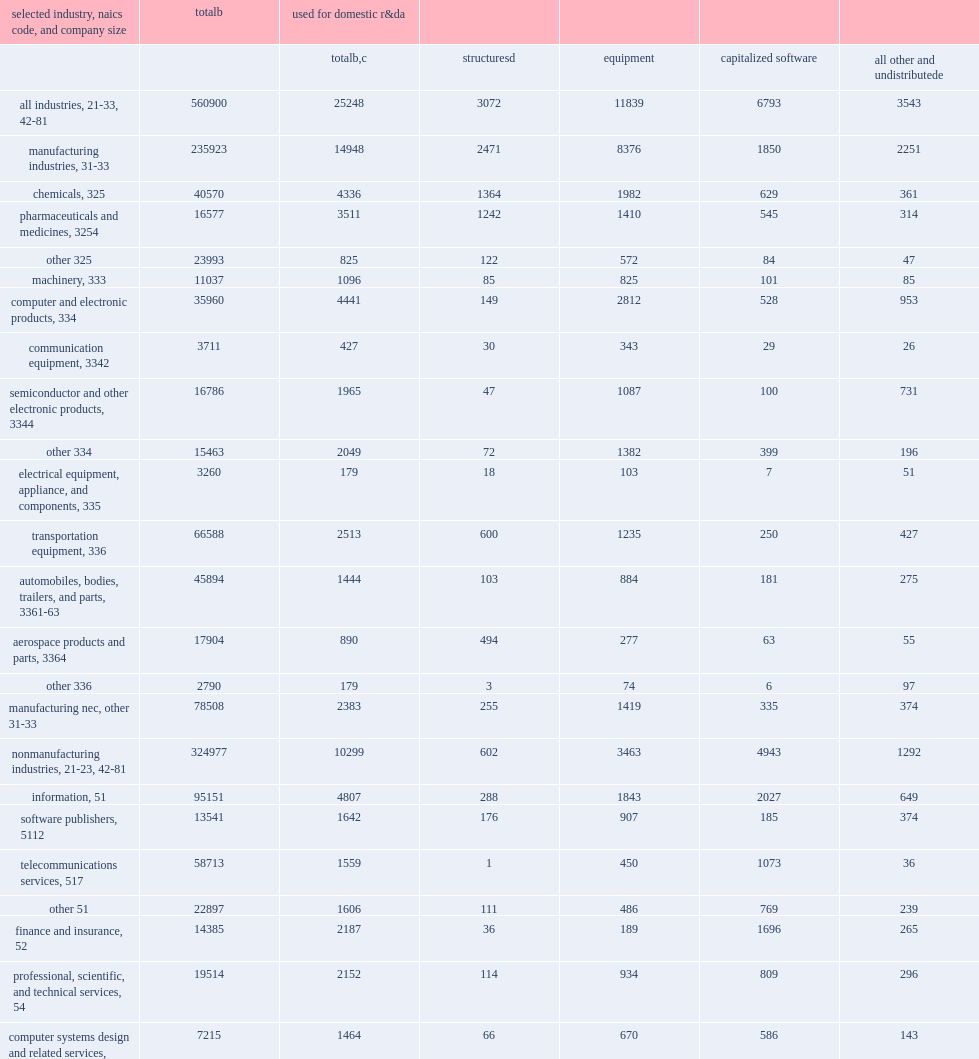How many million dollars did companies that performed or funded r&d in the united states in 2016 spend on assets with expected useful lives of more than 1 year? 560900.0. How many million dollars were spent on structures, equipment, software, and other assets used for r&d? 25248.0. How many million dollars were spent by manufacturing industries? 14948.0. How many million dollars were spent by nonmanufacturing industries? 10299.0. Give me the full table as a dictionary. {'header': ['selected industry, naics code, and company size', 'totalb', 'used for domestic r&da', '', '', '', ''], 'rows': [['', '', 'totalb,c', 'structuresd', 'equipment', 'capitalized software', 'all other and undistributede'], ['all industries, 21-33, 42-81', '560900', '25248', '3072', '11839', '6793', '3543'], ['manufacturing industries, 31-33', '235923', '14948', '2471', '8376', '1850', '2251'], ['chemicals, 325', '40570', '4336', '1364', '1982', '629', '361'], ['pharmaceuticals and medicines, 3254', '16577', '3511', '1242', '1410', '545', '314'], ['other 325', '23993', '825', '122', '572', '84', '47'], ['machinery, 333', '11037', '1096', '85', '825', '101', '85'], ['computer and electronic products, 334', '35960', '4441', '149', '2812', '528', '953'], ['communication equipment, 3342', '3711', '427', '30', '343', '29', '26'], ['semiconductor and other electronic products, 3344', '16786', '1965', '47', '1087', '100', '731'], ['other 334', '15463', '2049', '72', '1382', '399', '196'], ['electrical equipment, appliance, and components, 335', '3260', '179', '18', '103', '7', '51'], ['transportation equipment, 336', '66588', '2513', '600', '1235', '250', '427'], ['automobiles, bodies, trailers, and parts, 3361-63', '45894', '1444', '103', '884', '181', '275'], ['aerospace products and parts, 3364', '17904', '890', '494', '277', '63', '55'], ['other 336', '2790', '179', '3', '74', '6', '97'], ['manufacturing nec, other 31-33', '78508', '2383', '255', '1419', '335', '374'], ['nonmanufacturing industries, 21-23, 42-81', '324977', '10299', '602', '3463', '4943', '1292'], ['information, 51', '95151', '4807', '288', '1843', '2027', '649'], ['software publishers, 5112', '13541', '1642', '176', '907', '185', '374'], ['telecommunications services, 517', '58713', '1559', '1', '450', '1073', '36'], ['other 51', '22897', '1606', '111', '486', '769', '239'], ['finance and insurance, 52', '14385', '2187', '36', '189', '1696', '265'], ['professional, scientific, and technical services, 54', '19514', '2152', '114', '934', '809', '296'], ['computer systems design and related services, 5415', '7215', '1464', '66', '670', '586', '143'], ['scientific r&d services, 5417', '1552', '348', '39', '186', '16', '107'], ['other 54', '10747', '340', '9', '78', '207', '46'], ['nonmanufacturing nec, other 21-23, 42-81', '195927', '1153', '164', '497', '411', '82'], ['size of company', '', '', '', '', '', ''], ['micro companiesf', '', '', '', '', '', ''], ['5-9', '556', '75', '9', '44', '6', '16'], ['small companies', '', '', '', '', '', ''], ['10-19', '2967', '315', '20', '186', '26', '83'], ['20-49', '8005', '542', '41', '283', '119', '99'], ['medium companies', '', '', '', '', '', ''], ['50-99', '13984', '520', '60', '254', '102', '104'], ['100-249', '20113', '1212', '86', '489', '170', '468'], ['large companies', '', '', '', '', '', ''], ['250-499', '26216', '1337', '116', '597', '371', '253'], ['500-999', '17807', '1110', '66', '546', '279', '218'], ['1,000-4,999', '64733', '4208', '606', '1967', '1136', '499'], ['5,000-9,999', '53985', '2849', '445', '1466', '587', '351'], ['10,000-24,999', '105334', '5326', '804', '1928', '1532', '1062'], ['25,000 or more', '247200', '7754', '820', '4079', '2465', '390']]} 